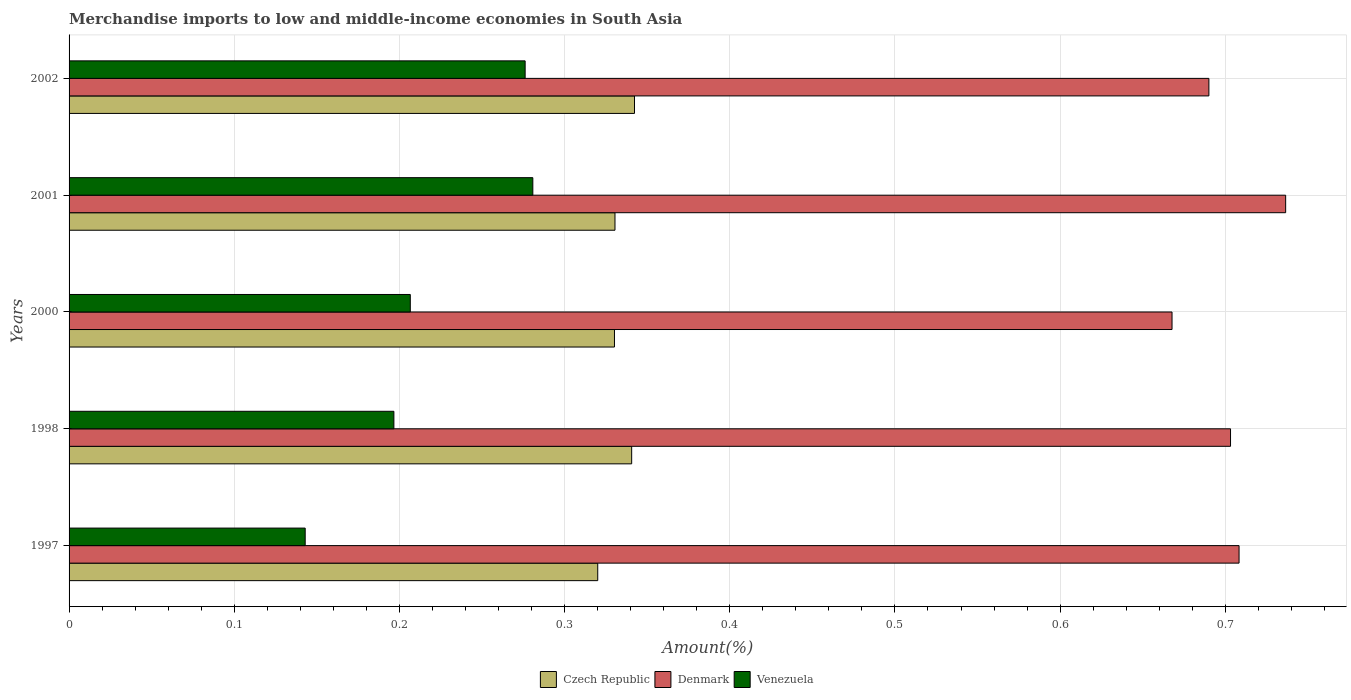How many bars are there on the 5th tick from the top?
Offer a very short reply. 3. How many bars are there on the 3rd tick from the bottom?
Provide a succinct answer. 3. What is the percentage of amount earned from merchandise imports in Czech Republic in 2002?
Your response must be concise. 0.34. Across all years, what is the maximum percentage of amount earned from merchandise imports in Czech Republic?
Your response must be concise. 0.34. Across all years, what is the minimum percentage of amount earned from merchandise imports in Czech Republic?
Offer a terse response. 0.32. In which year was the percentage of amount earned from merchandise imports in Czech Republic minimum?
Your response must be concise. 1997. What is the total percentage of amount earned from merchandise imports in Czech Republic in the graph?
Offer a terse response. 1.66. What is the difference between the percentage of amount earned from merchandise imports in Czech Republic in 1998 and that in 2002?
Offer a terse response. -0. What is the difference between the percentage of amount earned from merchandise imports in Czech Republic in 1998 and the percentage of amount earned from merchandise imports in Venezuela in 2001?
Your answer should be very brief. 0.06. What is the average percentage of amount earned from merchandise imports in Denmark per year?
Make the answer very short. 0.7. In the year 2000, what is the difference between the percentage of amount earned from merchandise imports in Czech Republic and percentage of amount earned from merchandise imports in Denmark?
Offer a very short reply. -0.34. What is the ratio of the percentage of amount earned from merchandise imports in Czech Republic in 1998 to that in 2001?
Offer a very short reply. 1.03. Is the percentage of amount earned from merchandise imports in Denmark in 2000 less than that in 2002?
Give a very brief answer. Yes. Is the difference between the percentage of amount earned from merchandise imports in Czech Republic in 1998 and 2000 greater than the difference between the percentage of amount earned from merchandise imports in Denmark in 1998 and 2000?
Your answer should be compact. No. What is the difference between the highest and the second highest percentage of amount earned from merchandise imports in Venezuela?
Your answer should be compact. 0. What is the difference between the highest and the lowest percentage of amount earned from merchandise imports in Denmark?
Make the answer very short. 0.07. Is the sum of the percentage of amount earned from merchandise imports in Czech Republic in 2000 and 2002 greater than the maximum percentage of amount earned from merchandise imports in Denmark across all years?
Provide a succinct answer. No. What does the 3rd bar from the top in 1998 represents?
Your answer should be very brief. Czech Republic. What does the 1st bar from the bottom in 2002 represents?
Offer a terse response. Czech Republic. How many bars are there?
Your answer should be compact. 15. How many years are there in the graph?
Offer a terse response. 5. What is the difference between two consecutive major ticks on the X-axis?
Provide a succinct answer. 0.1. Does the graph contain any zero values?
Ensure brevity in your answer.  No. Does the graph contain grids?
Your response must be concise. Yes. Where does the legend appear in the graph?
Ensure brevity in your answer.  Bottom center. How many legend labels are there?
Make the answer very short. 3. How are the legend labels stacked?
Provide a short and direct response. Horizontal. What is the title of the graph?
Provide a short and direct response. Merchandise imports to low and middle-income economies in South Asia. What is the label or title of the X-axis?
Offer a terse response. Amount(%). What is the label or title of the Y-axis?
Ensure brevity in your answer.  Years. What is the Amount(%) of Czech Republic in 1997?
Your answer should be compact. 0.32. What is the Amount(%) of Denmark in 1997?
Your response must be concise. 0.71. What is the Amount(%) in Venezuela in 1997?
Provide a succinct answer. 0.14. What is the Amount(%) of Czech Republic in 1998?
Give a very brief answer. 0.34. What is the Amount(%) in Denmark in 1998?
Give a very brief answer. 0.7. What is the Amount(%) of Venezuela in 1998?
Ensure brevity in your answer.  0.2. What is the Amount(%) in Czech Republic in 2000?
Provide a short and direct response. 0.33. What is the Amount(%) of Denmark in 2000?
Give a very brief answer. 0.67. What is the Amount(%) of Venezuela in 2000?
Make the answer very short. 0.21. What is the Amount(%) of Czech Republic in 2001?
Provide a succinct answer. 0.33. What is the Amount(%) of Denmark in 2001?
Provide a short and direct response. 0.74. What is the Amount(%) of Venezuela in 2001?
Ensure brevity in your answer.  0.28. What is the Amount(%) of Czech Republic in 2002?
Keep it short and to the point. 0.34. What is the Amount(%) of Denmark in 2002?
Ensure brevity in your answer.  0.69. What is the Amount(%) of Venezuela in 2002?
Your answer should be compact. 0.28. Across all years, what is the maximum Amount(%) of Czech Republic?
Make the answer very short. 0.34. Across all years, what is the maximum Amount(%) in Denmark?
Give a very brief answer. 0.74. Across all years, what is the maximum Amount(%) in Venezuela?
Provide a succinct answer. 0.28. Across all years, what is the minimum Amount(%) in Czech Republic?
Provide a succinct answer. 0.32. Across all years, what is the minimum Amount(%) of Denmark?
Keep it short and to the point. 0.67. Across all years, what is the minimum Amount(%) in Venezuela?
Your response must be concise. 0.14. What is the total Amount(%) of Czech Republic in the graph?
Make the answer very short. 1.66. What is the total Amount(%) of Denmark in the graph?
Offer a very short reply. 3.51. What is the total Amount(%) of Venezuela in the graph?
Your answer should be compact. 1.1. What is the difference between the Amount(%) in Czech Republic in 1997 and that in 1998?
Offer a terse response. -0.02. What is the difference between the Amount(%) in Denmark in 1997 and that in 1998?
Give a very brief answer. 0.01. What is the difference between the Amount(%) of Venezuela in 1997 and that in 1998?
Provide a short and direct response. -0.05. What is the difference between the Amount(%) of Czech Republic in 1997 and that in 2000?
Keep it short and to the point. -0.01. What is the difference between the Amount(%) of Denmark in 1997 and that in 2000?
Offer a very short reply. 0.04. What is the difference between the Amount(%) in Venezuela in 1997 and that in 2000?
Your response must be concise. -0.06. What is the difference between the Amount(%) in Czech Republic in 1997 and that in 2001?
Provide a succinct answer. -0.01. What is the difference between the Amount(%) of Denmark in 1997 and that in 2001?
Offer a very short reply. -0.03. What is the difference between the Amount(%) in Venezuela in 1997 and that in 2001?
Make the answer very short. -0.14. What is the difference between the Amount(%) of Czech Republic in 1997 and that in 2002?
Your answer should be compact. -0.02. What is the difference between the Amount(%) in Denmark in 1997 and that in 2002?
Your answer should be compact. 0.02. What is the difference between the Amount(%) of Venezuela in 1997 and that in 2002?
Provide a short and direct response. -0.13. What is the difference between the Amount(%) of Czech Republic in 1998 and that in 2000?
Your answer should be compact. 0.01. What is the difference between the Amount(%) of Denmark in 1998 and that in 2000?
Ensure brevity in your answer.  0.04. What is the difference between the Amount(%) in Venezuela in 1998 and that in 2000?
Give a very brief answer. -0.01. What is the difference between the Amount(%) in Czech Republic in 1998 and that in 2001?
Provide a short and direct response. 0.01. What is the difference between the Amount(%) of Denmark in 1998 and that in 2001?
Offer a terse response. -0.03. What is the difference between the Amount(%) of Venezuela in 1998 and that in 2001?
Make the answer very short. -0.08. What is the difference between the Amount(%) of Czech Republic in 1998 and that in 2002?
Make the answer very short. -0. What is the difference between the Amount(%) of Denmark in 1998 and that in 2002?
Provide a succinct answer. 0.01. What is the difference between the Amount(%) in Venezuela in 1998 and that in 2002?
Ensure brevity in your answer.  -0.08. What is the difference between the Amount(%) of Czech Republic in 2000 and that in 2001?
Give a very brief answer. -0. What is the difference between the Amount(%) of Denmark in 2000 and that in 2001?
Your response must be concise. -0.07. What is the difference between the Amount(%) in Venezuela in 2000 and that in 2001?
Provide a succinct answer. -0.07. What is the difference between the Amount(%) of Czech Republic in 2000 and that in 2002?
Make the answer very short. -0.01. What is the difference between the Amount(%) in Denmark in 2000 and that in 2002?
Make the answer very short. -0.02. What is the difference between the Amount(%) in Venezuela in 2000 and that in 2002?
Keep it short and to the point. -0.07. What is the difference between the Amount(%) in Czech Republic in 2001 and that in 2002?
Provide a short and direct response. -0.01. What is the difference between the Amount(%) in Denmark in 2001 and that in 2002?
Your answer should be very brief. 0.05. What is the difference between the Amount(%) in Venezuela in 2001 and that in 2002?
Make the answer very short. 0. What is the difference between the Amount(%) of Czech Republic in 1997 and the Amount(%) of Denmark in 1998?
Ensure brevity in your answer.  -0.38. What is the difference between the Amount(%) in Czech Republic in 1997 and the Amount(%) in Venezuela in 1998?
Your answer should be compact. 0.12. What is the difference between the Amount(%) of Denmark in 1997 and the Amount(%) of Venezuela in 1998?
Keep it short and to the point. 0.51. What is the difference between the Amount(%) of Czech Republic in 1997 and the Amount(%) of Denmark in 2000?
Your answer should be very brief. -0.35. What is the difference between the Amount(%) in Czech Republic in 1997 and the Amount(%) in Venezuela in 2000?
Keep it short and to the point. 0.11. What is the difference between the Amount(%) of Denmark in 1997 and the Amount(%) of Venezuela in 2000?
Offer a very short reply. 0.5. What is the difference between the Amount(%) in Czech Republic in 1997 and the Amount(%) in Denmark in 2001?
Your answer should be very brief. -0.42. What is the difference between the Amount(%) of Czech Republic in 1997 and the Amount(%) of Venezuela in 2001?
Offer a terse response. 0.04. What is the difference between the Amount(%) in Denmark in 1997 and the Amount(%) in Venezuela in 2001?
Offer a terse response. 0.43. What is the difference between the Amount(%) of Czech Republic in 1997 and the Amount(%) of Denmark in 2002?
Offer a terse response. -0.37. What is the difference between the Amount(%) of Czech Republic in 1997 and the Amount(%) of Venezuela in 2002?
Make the answer very short. 0.04. What is the difference between the Amount(%) of Denmark in 1997 and the Amount(%) of Venezuela in 2002?
Provide a succinct answer. 0.43. What is the difference between the Amount(%) of Czech Republic in 1998 and the Amount(%) of Denmark in 2000?
Your answer should be very brief. -0.33. What is the difference between the Amount(%) of Czech Republic in 1998 and the Amount(%) of Venezuela in 2000?
Provide a succinct answer. 0.13. What is the difference between the Amount(%) of Denmark in 1998 and the Amount(%) of Venezuela in 2000?
Your answer should be very brief. 0.5. What is the difference between the Amount(%) in Czech Republic in 1998 and the Amount(%) in Denmark in 2001?
Your answer should be compact. -0.4. What is the difference between the Amount(%) in Czech Republic in 1998 and the Amount(%) in Venezuela in 2001?
Offer a very short reply. 0.06. What is the difference between the Amount(%) of Denmark in 1998 and the Amount(%) of Venezuela in 2001?
Give a very brief answer. 0.42. What is the difference between the Amount(%) in Czech Republic in 1998 and the Amount(%) in Denmark in 2002?
Offer a very short reply. -0.35. What is the difference between the Amount(%) of Czech Republic in 1998 and the Amount(%) of Venezuela in 2002?
Your answer should be very brief. 0.06. What is the difference between the Amount(%) in Denmark in 1998 and the Amount(%) in Venezuela in 2002?
Offer a terse response. 0.43. What is the difference between the Amount(%) in Czech Republic in 2000 and the Amount(%) in Denmark in 2001?
Your answer should be compact. -0.41. What is the difference between the Amount(%) in Czech Republic in 2000 and the Amount(%) in Venezuela in 2001?
Your answer should be very brief. 0.05. What is the difference between the Amount(%) in Denmark in 2000 and the Amount(%) in Venezuela in 2001?
Make the answer very short. 0.39. What is the difference between the Amount(%) in Czech Republic in 2000 and the Amount(%) in Denmark in 2002?
Your answer should be compact. -0.36. What is the difference between the Amount(%) in Czech Republic in 2000 and the Amount(%) in Venezuela in 2002?
Offer a terse response. 0.05. What is the difference between the Amount(%) of Denmark in 2000 and the Amount(%) of Venezuela in 2002?
Your answer should be compact. 0.39. What is the difference between the Amount(%) in Czech Republic in 2001 and the Amount(%) in Denmark in 2002?
Offer a terse response. -0.36. What is the difference between the Amount(%) of Czech Republic in 2001 and the Amount(%) of Venezuela in 2002?
Give a very brief answer. 0.05. What is the difference between the Amount(%) in Denmark in 2001 and the Amount(%) in Venezuela in 2002?
Ensure brevity in your answer.  0.46. What is the average Amount(%) of Czech Republic per year?
Provide a short and direct response. 0.33. What is the average Amount(%) in Denmark per year?
Ensure brevity in your answer.  0.7. What is the average Amount(%) of Venezuela per year?
Offer a terse response. 0.22. In the year 1997, what is the difference between the Amount(%) in Czech Republic and Amount(%) in Denmark?
Make the answer very short. -0.39. In the year 1997, what is the difference between the Amount(%) in Czech Republic and Amount(%) in Venezuela?
Offer a very short reply. 0.18. In the year 1997, what is the difference between the Amount(%) in Denmark and Amount(%) in Venezuela?
Make the answer very short. 0.57. In the year 1998, what is the difference between the Amount(%) in Czech Republic and Amount(%) in Denmark?
Make the answer very short. -0.36. In the year 1998, what is the difference between the Amount(%) in Czech Republic and Amount(%) in Venezuela?
Your answer should be compact. 0.14. In the year 1998, what is the difference between the Amount(%) in Denmark and Amount(%) in Venezuela?
Your answer should be very brief. 0.51. In the year 2000, what is the difference between the Amount(%) of Czech Republic and Amount(%) of Denmark?
Keep it short and to the point. -0.34. In the year 2000, what is the difference between the Amount(%) of Czech Republic and Amount(%) of Venezuela?
Offer a terse response. 0.12. In the year 2000, what is the difference between the Amount(%) in Denmark and Amount(%) in Venezuela?
Keep it short and to the point. 0.46. In the year 2001, what is the difference between the Amount(%) of Czech Republic and Amount(%) of Denmark?
Provide a succinct answer. -0.41. In the year 2001, what is the difference between the Amount(%) in Czech Republic and Amount(%) in Venezuela?
Your answer should be very brief. 0.05. In the year 2001, what is the difference between the Amount(%) of Denmark and Amount(%) of Venezuela?
Your answer should be very brief. 0.46. In the year 2002, what is the difference between the Amount(%) in Czech Republic and Amount(%) in Denmark?
Keep it short and to the point. -0.35. In the year 2002, what is the difference between the Amount(%) of Czech Republic and Amount(%) of Venezuela?
Offer a very short reply. 0.07. In the year 2002, what is the difference between the Amount(%) of Denmark and Amount(%) of Venezuela?
Your response must be concise. 0.41. What is the ratio of the Amount(%) in Czech Republic in 1997 to that in 1998?
Your answer should be very brief. 0.94. What is the ratio of the Amount(%) of Denmark in 1997 to that in 1998?
Give a very brief answer. 1.01. What is the ratio of the Amount(%) in Venezuela in 1997 to that in 1998?
Offer a very short reply. 0.73. What is the ratio of the Amount(%) in Czech Republic in 1997 to that in 2000?
Provide a short and direct response. 0.97. What is the ratio of the Amount(%) in Denmark in 1997 to that in 2000?
Keep it short and to the point. 1.06. What is the ratio of the Amount(%) in Venezuela in 1997 to that in 2000?
Offer a terse response. 0.69. What is the ratio of the Amount(%) of Czech Republic in 1997 to that in 2001?
Keep it short and to the point. 0.97. What is the ratio of the Amount(%) in Denmark in 1997 to that in 2001?
Your response must be concise. 0.96. What is the ratio of the Amount(%) of Venezuela in 1997 to that in 2001?
Offer a terse response. 0.51. What is the ratio of the Amount(%) of Czech Republic in 1997 to that in 2002?
Keep it short and to the point. 0.94. What is the ratio of the Amount(%) in Denmark in 1997 to that in 2002?
Provide a short and direct response. 1.03. What is the ratio of the Amount(%) in Venezuela in 1997 to that in 2002?
Your answer should be compact. 0.52. What is the ratio of the Amount(%) in Czech Republic in 1998 to that in 2000?
Offer a terse response. 1.03. What is the ratio of the Amount(%) in Denmark in 1998 to that in 2000?
Make the answer very short. 1.05. What is the ratio of the Amount(%) in Venezuela in 1998 to that in 2000?
Offer a terse response. 0.95. What is the ratio of the Amount(%) of Czech Republic in 1998 to that in 2001?
Keep it short and to the point. 1.03. What is the ratio of the Amount(%) in Denmark in 1998 to that in 2001?
Provide a succinct answer. 0.95. What is the ratio of the Amount(%) in Venezuela in 1998 to that in 2001?
Your answer should be very brief. 0.7. What is the ratio of the Amount(%) of Czech Republic in 1998 to that in 2002?
Provide a succinct answer. 0.99. What is the ratio of the Amount(%) in Venezuela in 1998 to that in 2002?
Provide a succinct answer. 0.71. What is the ratio of the Amount(%) in Czech Republic in 2000 to that in 2001?
Keep it short and to the point. 1. What is the ratio of the Amount(%) of Denmark in 2000 to that in 2001?
Provide a short and direct response. 0.91. What is the ratio of the Amount(%) in Venezuela in 2000 to that in 2001?
Make the answer very short. 0.74. What is the ratio of the Amount(%) of Czech Republic in 2000 to that in 2002?
Keep it short and to the point. 0.96. What is the ratio of the Amount(%) of Venezuela in 2000 to that in 2002?
Ensure brevity in your answer.  0.75. What is the ratio of the Amount(%) of Czech Republic in 2001 to that in 2002?
Offer a terse response. 0.97. What is the ratio of the Amount(%) of Denmark in 2001 to that in 2002?
Offer a terse response. 1.07. What is the ratio of the Amount(%) of Venezuela in 2001 to that in 2002?
Your answer should be compact. 1.02. What is the difference between the highest and the second highest Amount(%) of Czech Republic?
Offer a very short reply. 0. What is the difference between the highest and the second highest Amount(%) of Denmark?
Ensure brevity in your answer.  0.03. What is the difference between the highest and the second highest Amount(%) of Venezuela?
Your response must be concise. 0. What is the difference between the highest and the lowest Amount(%) of Czech Republic?
Your answer should be compact. 0.02. What is the difference between the highest and the lowest Amount(%) in Denmark?
Make the answer very short. 0.07. What is the difference between the highest and the lowest Amount(%) in Venezuela?
Provide a short and direct response. 0.14. 